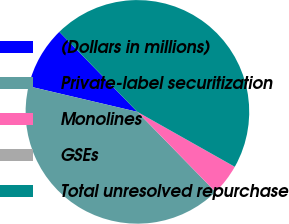Convert chart. <chart><loc_0><loc_0><loc_500><loc_500><pie_chart><fcel>(Dollars in millions)<fcel>Private-label securitization<fcel>Monolines<fcel>GSEs<fcel>Total unresolved repurchase<nl><fcel>9.01%<fcel>40.99%<fcel>4.51%<fcel>0.01%<fcel>45.48%<nl></chart> 